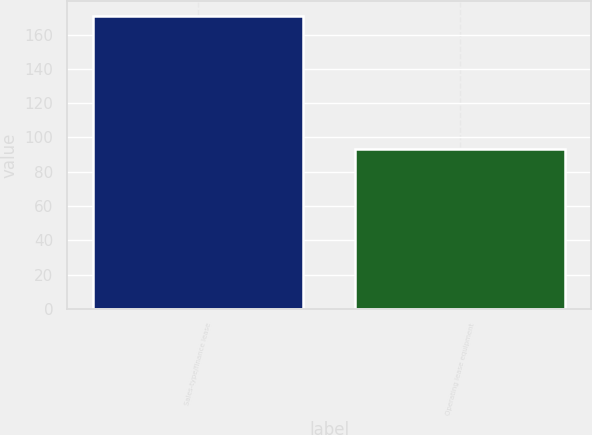Convert chart to OTSL. <chart><loc_0><loc_0><loc_500><loc_500><bar_chart><fcel>Sales-type/finance lease<fcel>Operating lease equipment<nl><fcel>171<fcel>93<nl></chart> 